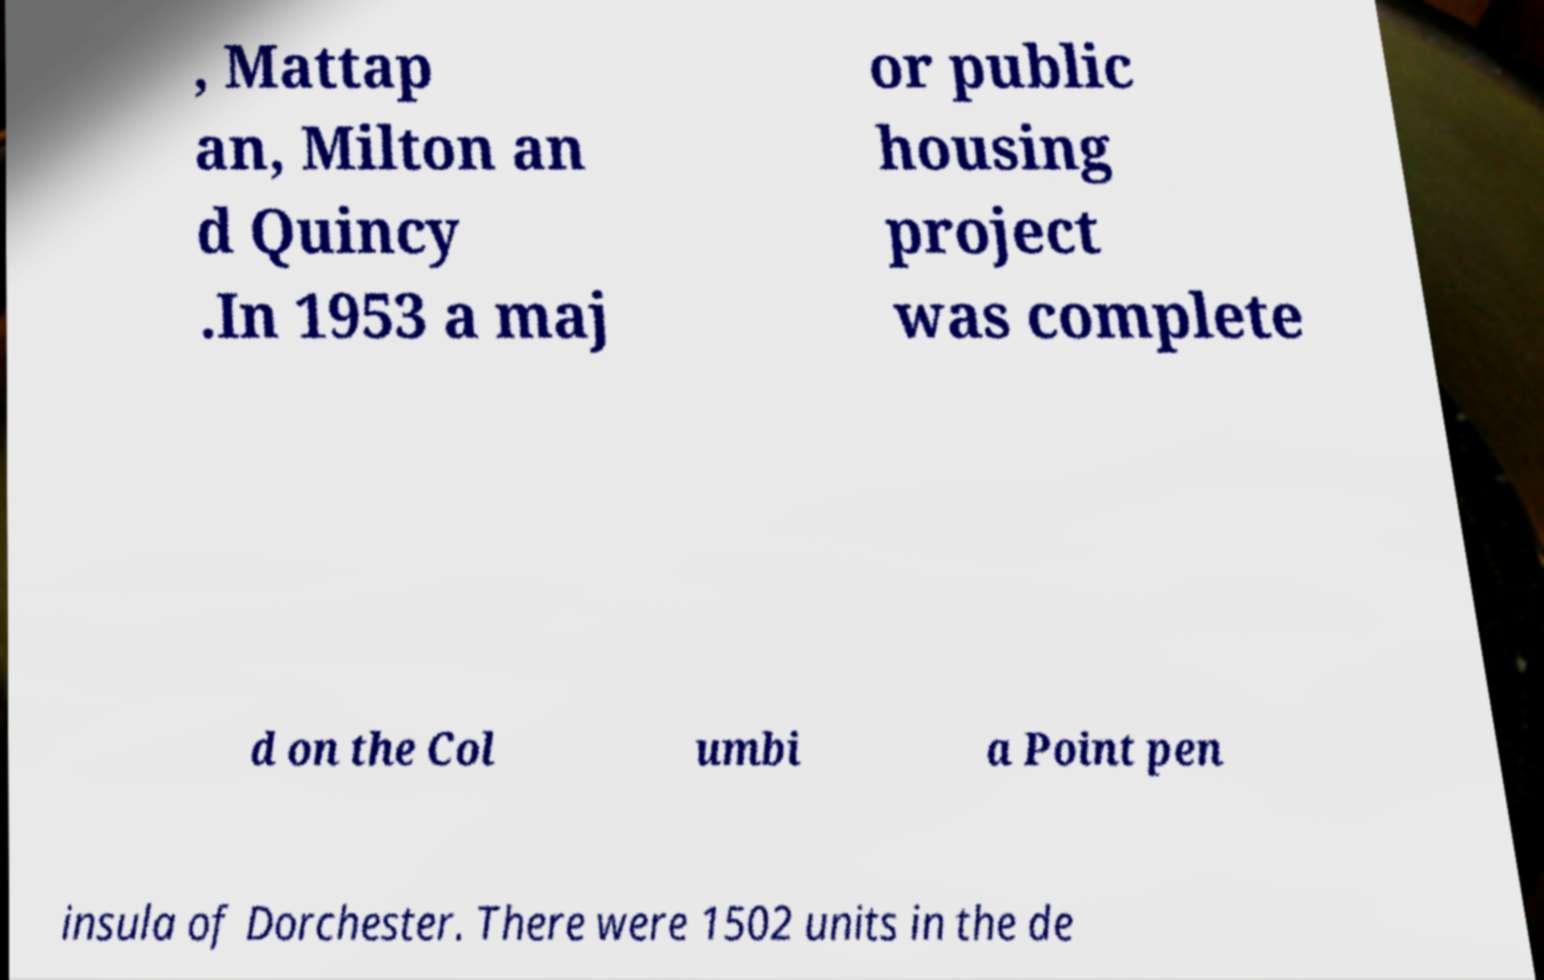What messages or text are displayed in this image? I need them in a readable, typed format. , Mattap an, Milton an d Quincy .In 1953 a maj or public housing project was complete d on the Col umbi a Point pen insula of Dorchester. There were 1502 units in the de 